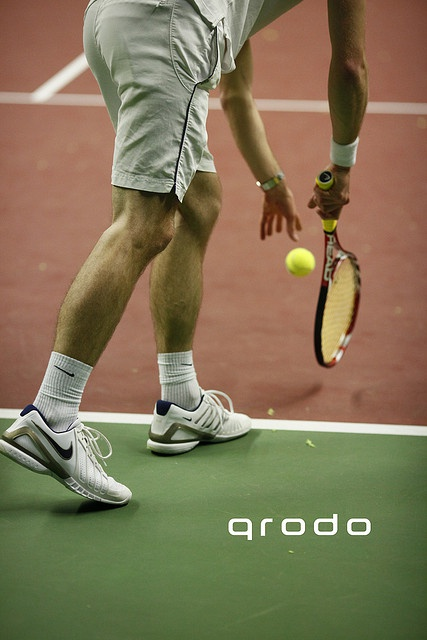Describe the objects in this image and their specific colors. I can see people in brown, darkgray, olive, and gray tones, tennis racket in brown, tan, black, and maroon tones, and sports ball in brown, khaki, olive, and tan tones in this image. 